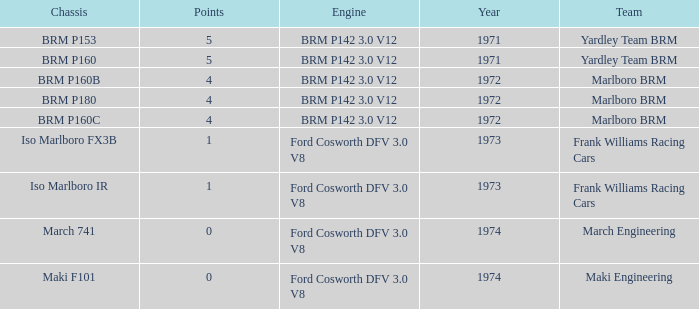What are the highest points for the team of marlboro brm with brm p180 as the chassis? 4.0. 